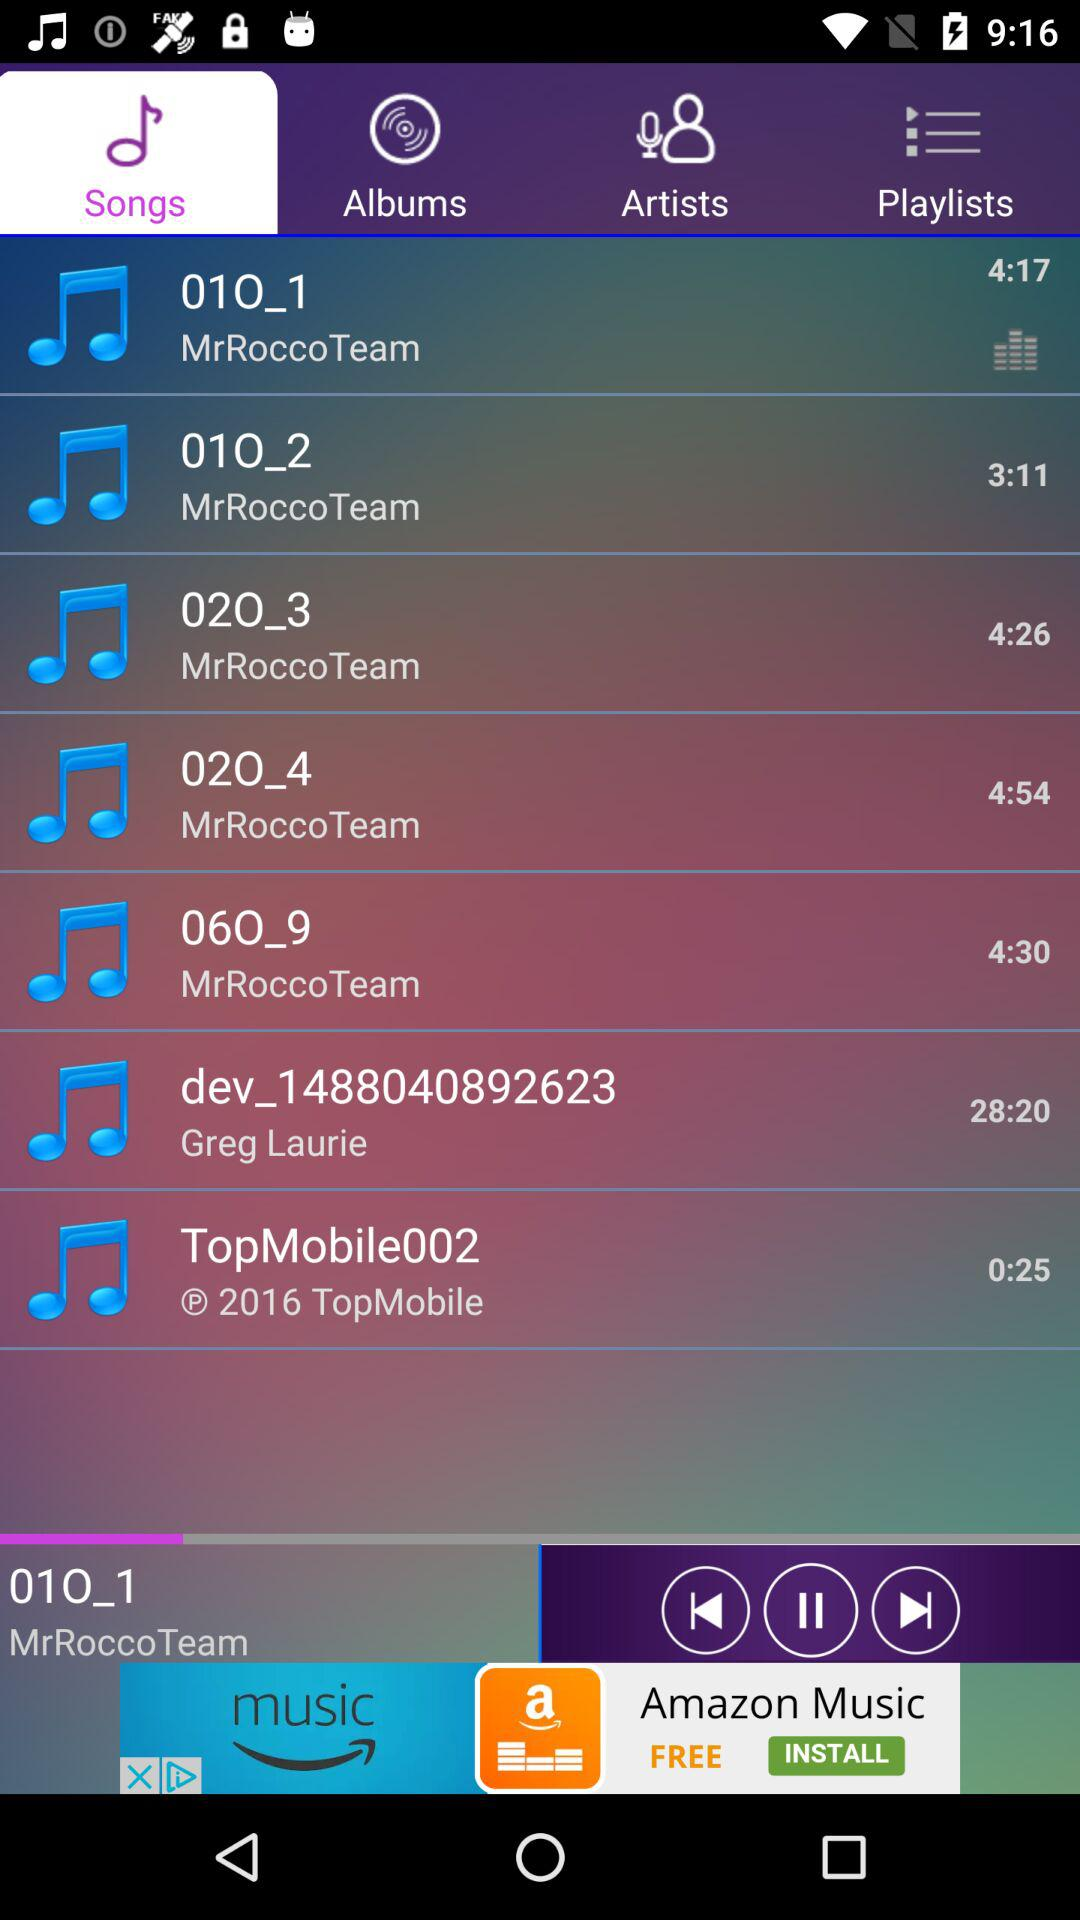Which song is playing? The song that is playing is "01O_1". 